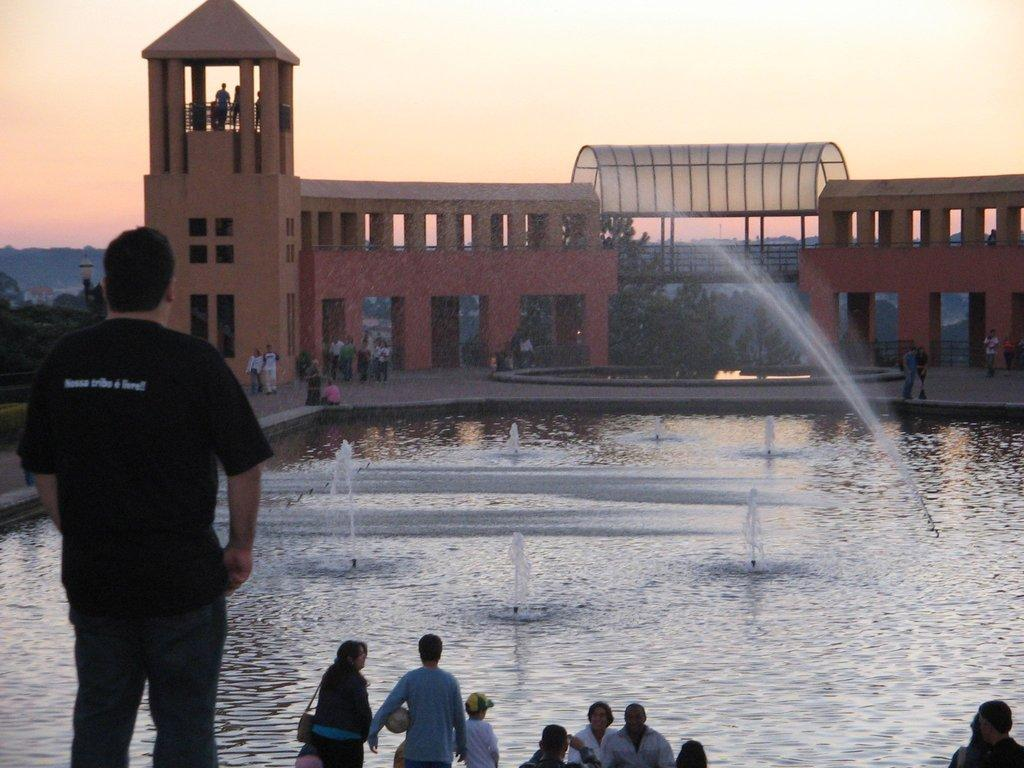What is the main subject in the foreground of the image? There is a man standing in the foreground of the image. What can be seen in the background of the image? There are persons, water, a sprinkling of water, a building, trees, poles, and the sky visible in the background of the image. How many elements are present in the background of the image? There are eight elements present in the background: persons, water, a sprinkling of water, a building, trees, poles, and the sky. What type of songs can be heard coming from the man's ear in the image? There is no indication in the image that the man has any songs playing in his ear, so it's not possible to determine what, if any, songs might be heard. 